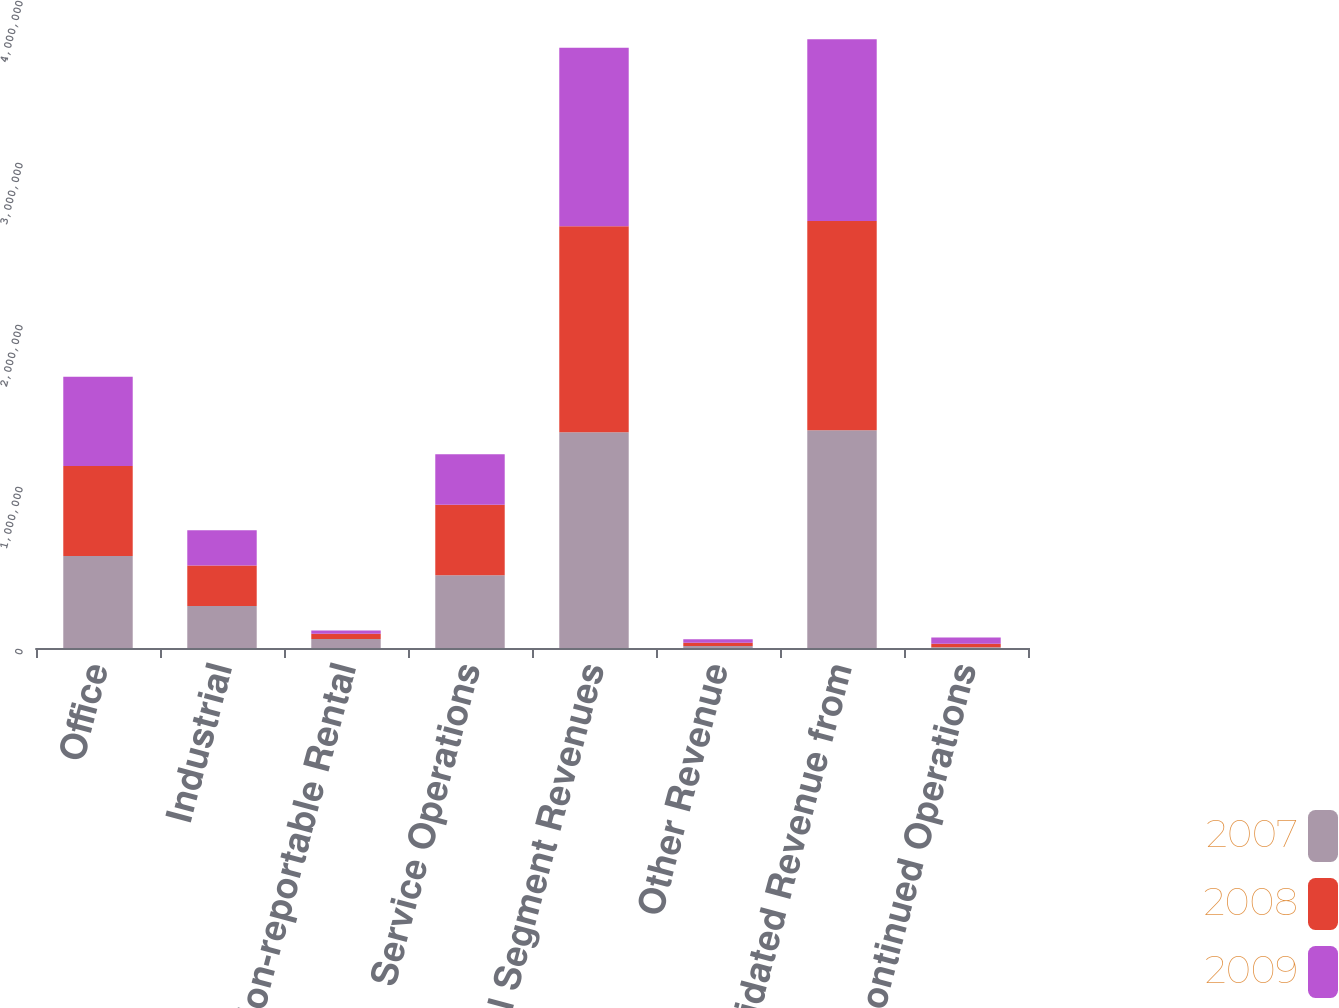Convert chart. <chart><loc_0><loc_0><loc_500><loc_500><stacked_bar_chart><ecel><fcel>Office<fcel>Industrial<fcel>Non-reportable Rental<fcel>Service Operations<fcel>Total Segment Revenues<fcel>Other Revenue<fcel>Consolidated Revenue from<fcel>Discontinued Operations<nl><fcel>2007<fcel>568074<fcel>258888<fcel>55241<fcel>449509<fcel>1.33171e+06<fcel>12377<fcel>1.34409e+06<fcel>4115<nl><fcel>2008<fcel>555592<fcel>250078<fcel>31987<fcel>434624<fcel>1.27228e+06<fcel>19902<fcel>1.29218e+06<fcel>21825<nl><fcel>2009<fcel>550116<fcel>218055<fcel>20952<fcel>311548<fcel>1.10067e+06<fcel>21424<fcel>1.1221e+06<fcel>39504<nl></chart> 